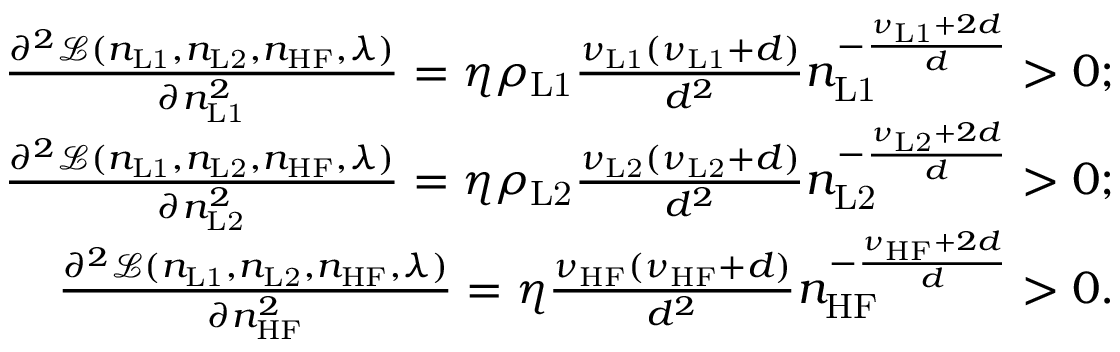Convert formula to latex. <formula><loc_0><loc_0><loc_500><loc_500>\begin{array} { r } { \frac { \partial ^ { 2 } \mathcal { L } ( n _ { L 1 } , n _ { L 2 } , n _ { H F } , \lambda ) } { \partial n _ { L 1 } ^ { 2 } } = \eta \rho _ { L 1 } \frac { \nu _ { L 1 } ( \nu _ { L 1 } + d ) } { d ^ { 2 } } n _ { L 1 } ^ { - \frac { \nu _ { L 1 } + 2 d } { d } } > 0 ; } \\ { \frac { \partial ^ { 2 } \mathcal { L } ( n _ { L 1 } , n _ { L 2 } , n _ { H F } , \lambda ) } { \partial n _ { L 2 } ^ { 2 } } = \eta \rho _ { L 2 } \frac { \nu _ { L 2 } ( \nu _ { L 2 } + d ) } { d ^ { 2 } } n _ { L 2 } ^ { - \frac { \nu _ { L 2 } + 2 d } { d } } > 0 ; } \\ { \frac { \partial ^ { 2 } \mathcal { L } ( n _ { L 1 } , n _ { L 2 } , n _ { H F } , \lambda ) } { \partial n _ { H F } ^ { 2 } } = \eta \frac { \nu _ { H F } ( \nu _ { H F } + d ) } { d ^ { 2 } } n _ { H F } ^ { - \frac { \nu _ { H F } + 2 d } { d } } > 0 . } \end{array}</formula> 